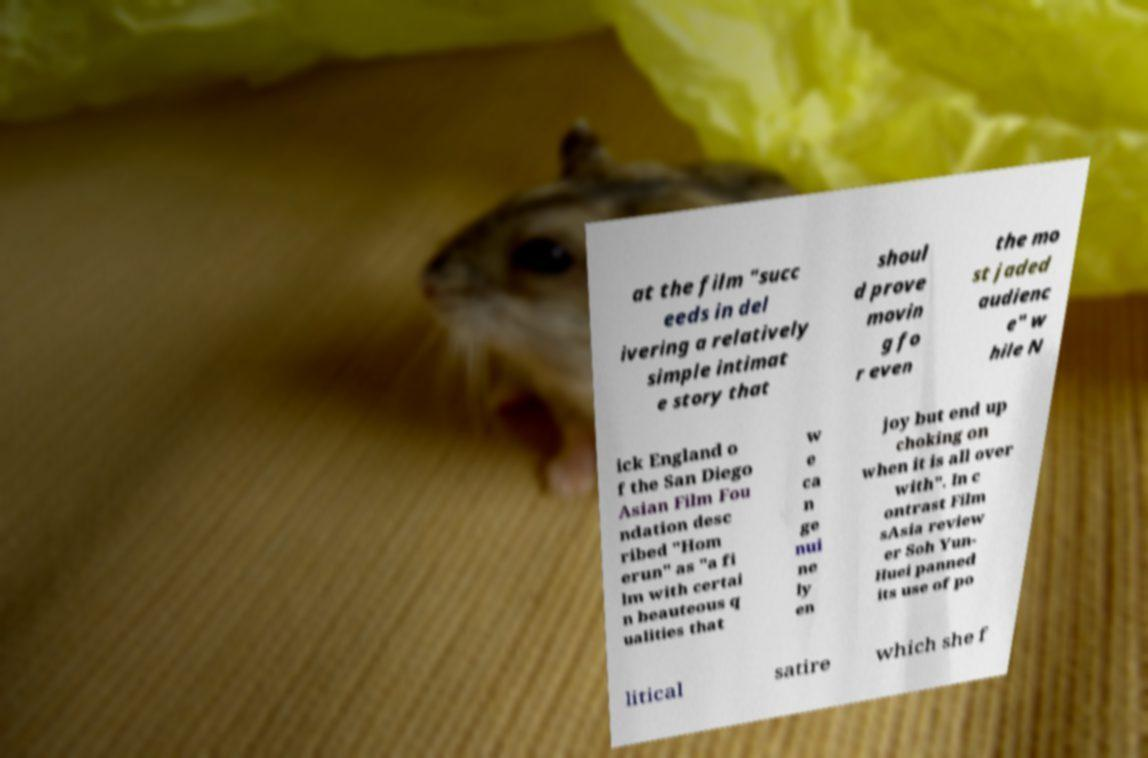I need the written content from this picture converted into text. Can you do that? at the film "succ eeds in del ivering a relatively simple intimat e story that shoul d prove movin g fo r even the mo st jaded audienc e" w hile N ick England o f the San Diego Asian Film Fou ndation desc ribed "Hom erun" as "a fi lm with certai n beauteous q ualities that w e ca n ge nui ne ly en joy but end up choking on when it is all over with". In c ontrast Film sAsia review er Soh Yun- Huei panned its use of po litical satire which she f 